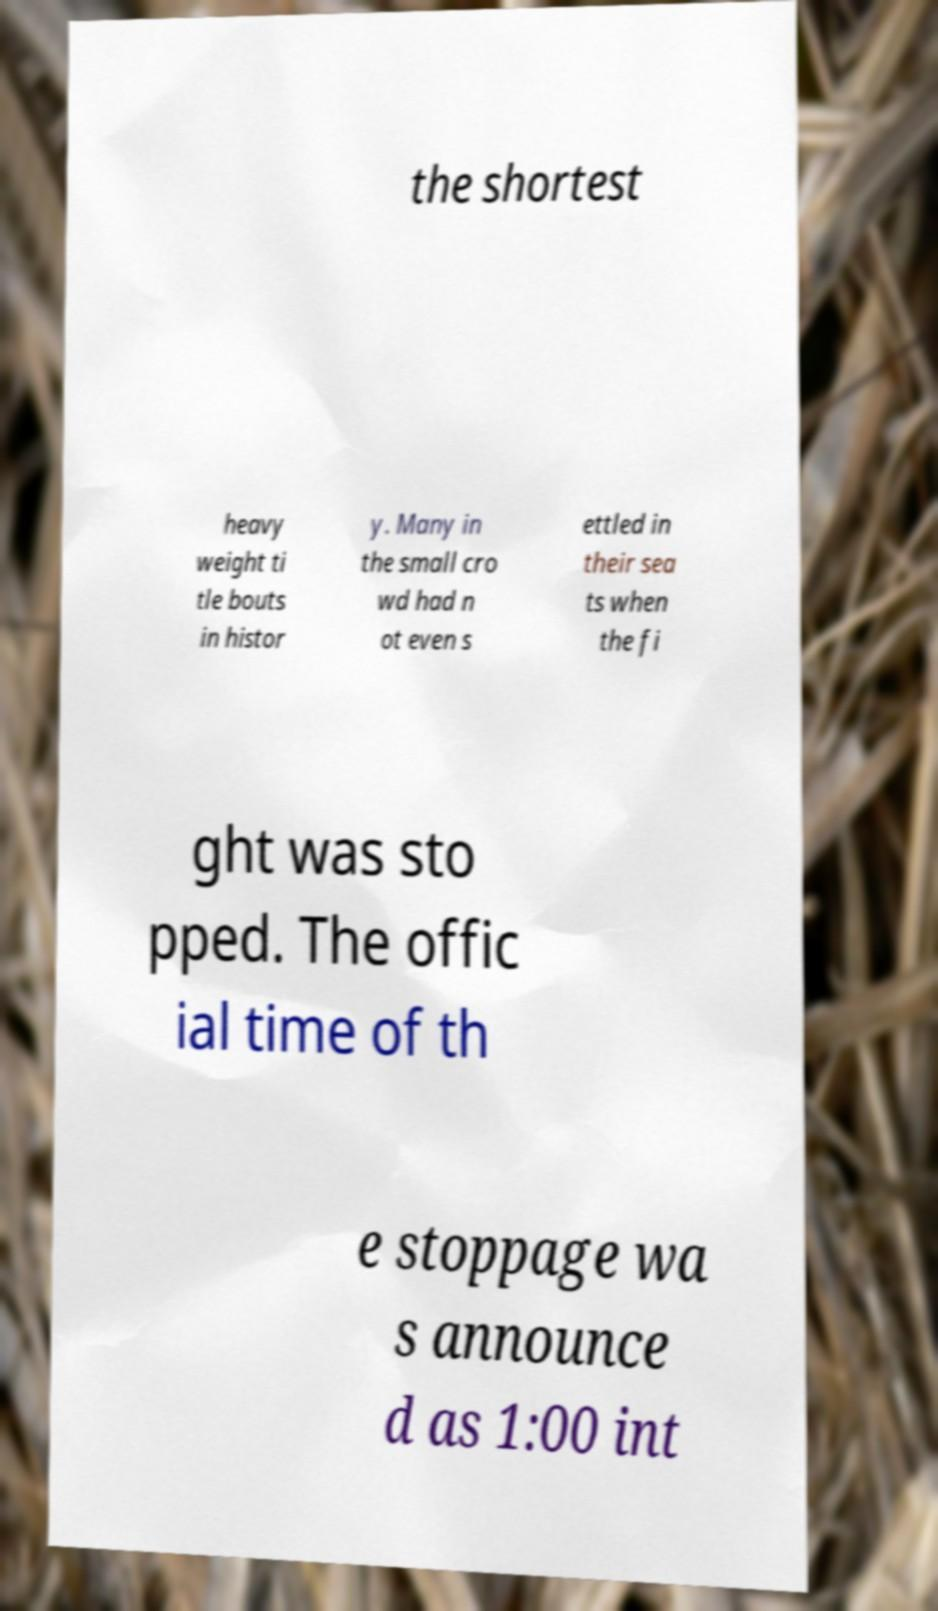Please identify and transcribe the text found in this image. the shortest heavy weight ti tle bouts in histor y. Many in the small cro wd had n ot even s ettled in their sea ts when the fi ght was sto pped. The offic ial time of th e stoppage wa s announce d as 1:00 int 